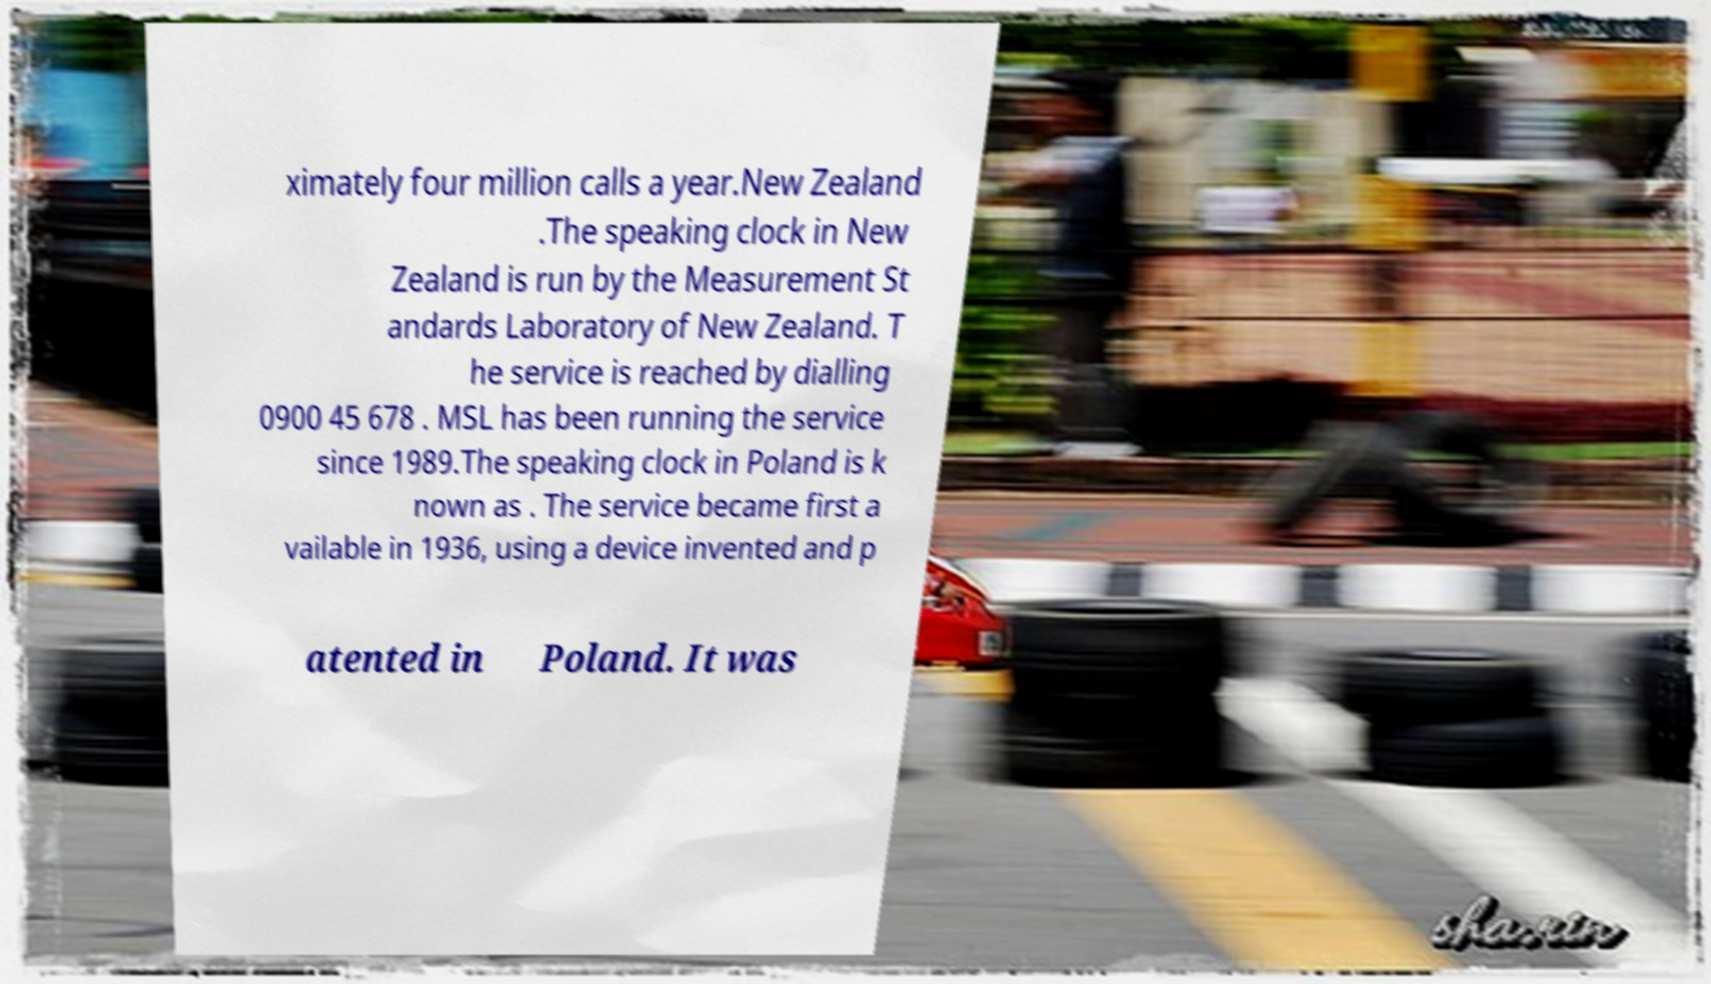Can you accurately transcribe the text from the provided image for me? ximately four million calls a year.New Zealand .The speaking clock in New Zealand is run by the Measurement St andards Laboratory of New Zealand. T he service is reached by dialling 0900 45 678 . MSL has been running the service since 1989.The speaking clock in Poland is k nown as . The service became first a vailable in 1936, using a device invented and p atented in Poland. It was 